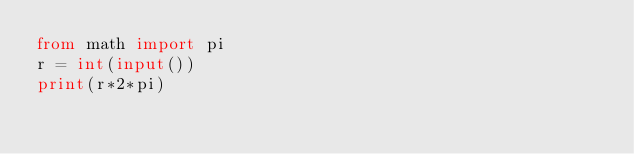Convert code to text. <code><loc_0><loc_0><loc_500><loc_500><_Python_>from math import pi
r = int(input())
print(r*2*pi)</code> 